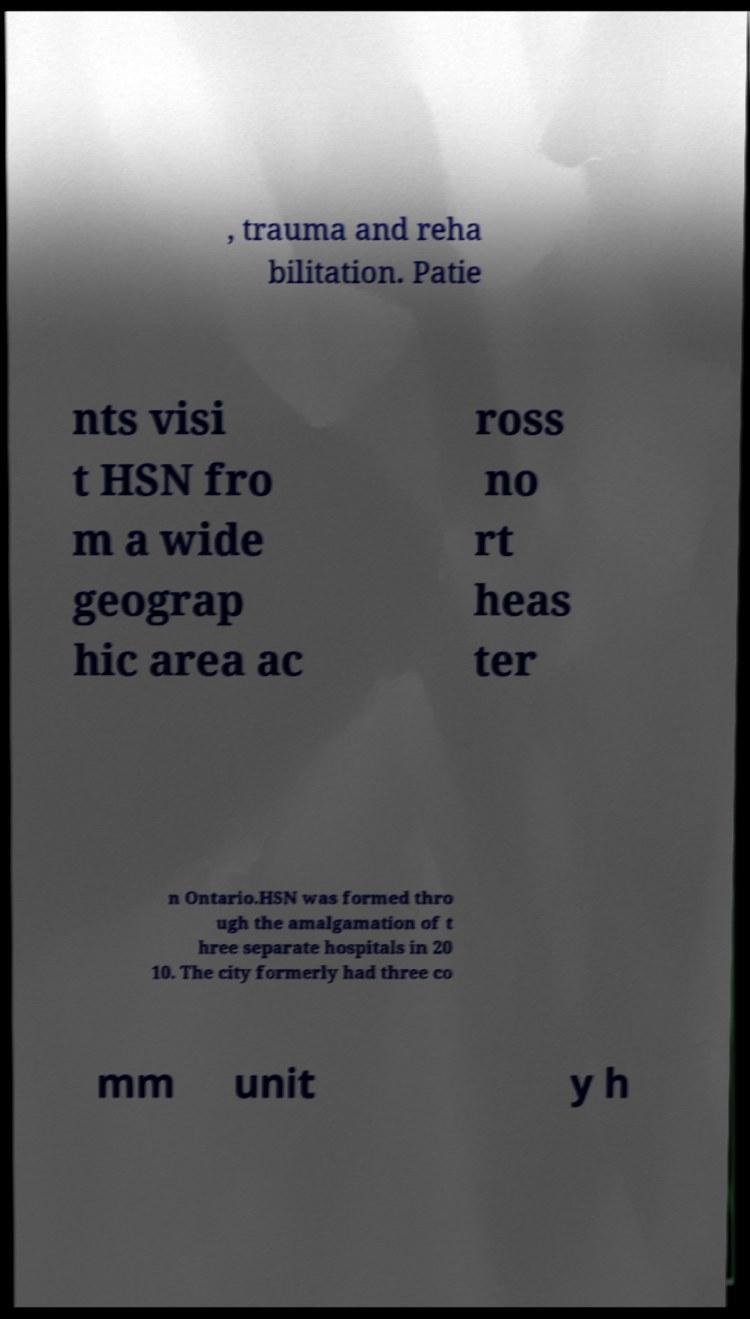Could you assist in decoding the text presented in this image and type it out clearly? , trauma and reha bilitation. Patie nts visi t HSN fro m a wide geograp hic area ac ross no rt heas ter n Ontario.HSN was formed thro ugh the amalgamation of t hree separate hospitals in 20 10. The city formerly had three co mm unit y h 